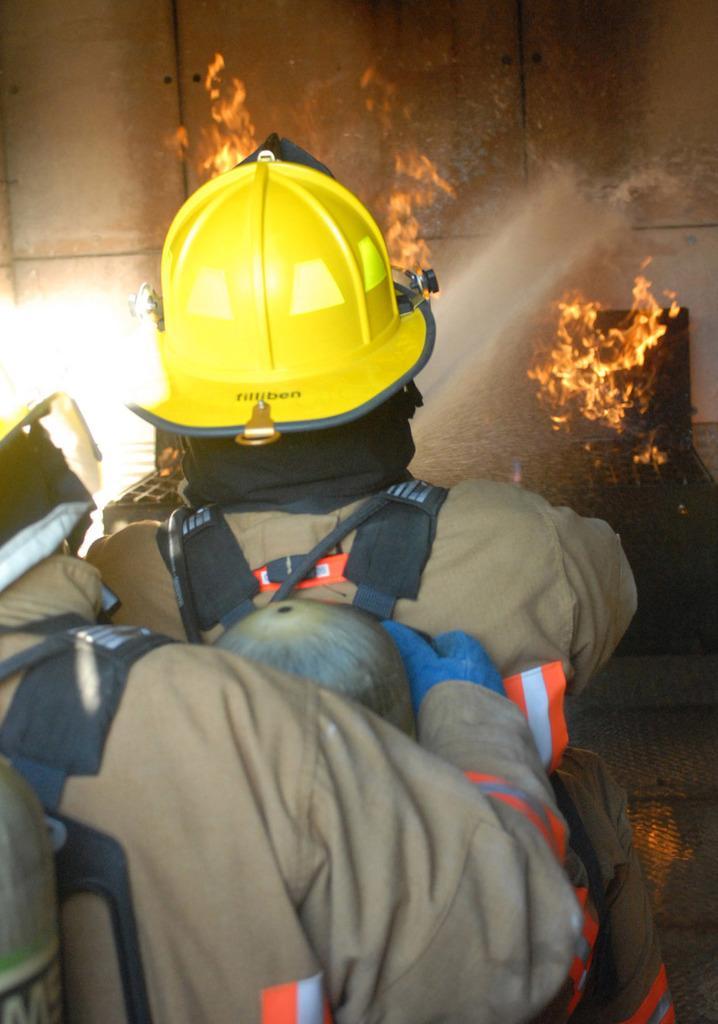How would you summarize this image in a sentence or two? Here we can see two persons and among them a person has helmet on his head and carrying a cylinder bag on his shoulders and he is watering on the fire and this is a wall. 